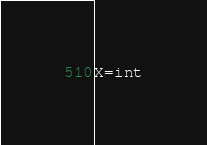<code> <loc_0><loc_0><loc_500><loc_500><_Python_>X=int</code> 